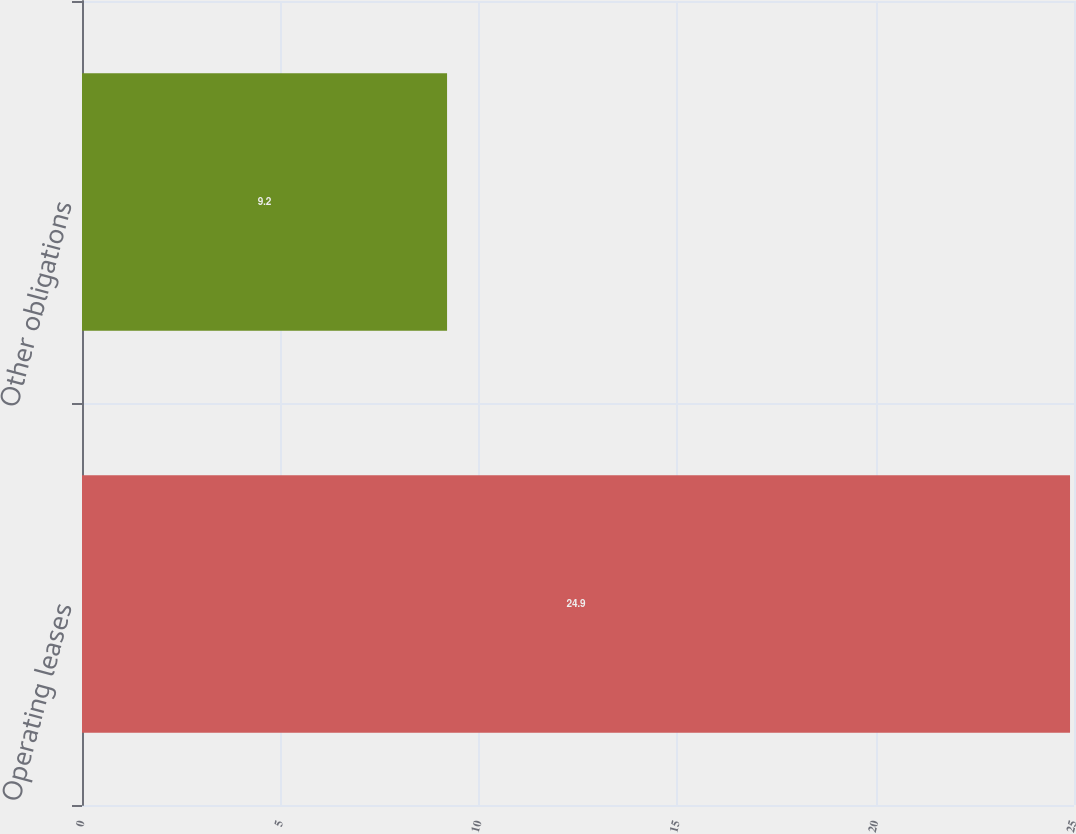Convert chart to OTSL. <chart><loc_0><loc_0><loc_500><loc_500><bar_chart><fcel>Operating leases<fcel>Other obligations<nl><fcel>24.9<fcel>9.2<nl></chart> 